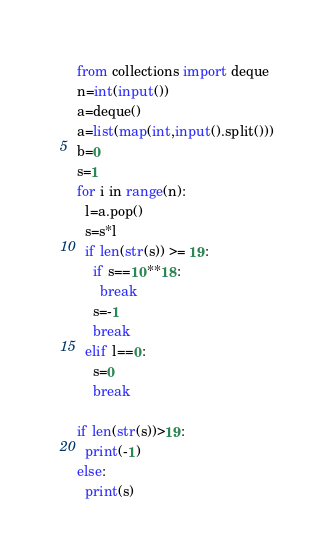Convert code to text. <code><loc_0><loc_0><loc_500><loc_500><_Python_>from collections import deque
n=int(input())
a=deque()
a=list(map(int,input().split()))
b=0
s=1
for i in range(n):
  l=a.pop()
  s=s*l
  if len(str(s)) >= 19:
    if s==10**18:
      break
    s=-1
    break
  elif l==0:
    s=0
    break

if len(str(s))>19:
  print(-1)
else:
  print(s)</code> 